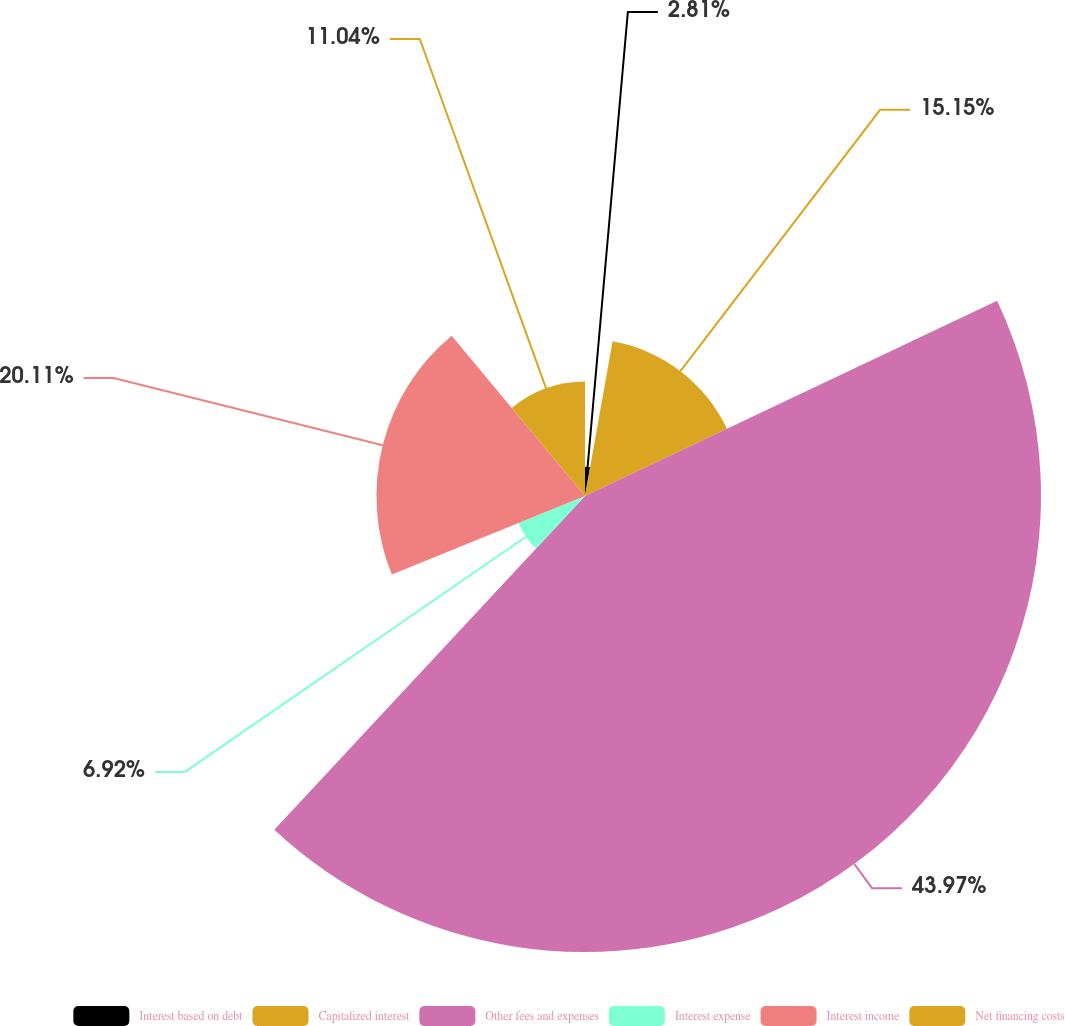<chart> <loc_0><loc_0><loc_500><loc_500><pie_chart><fcel>Interest based on debt<fcel>Capitalized interest<fcel>Other fees and expenses<fcel>Interest expense<fcel>Interest income<fcel>Net financing costs<nl><fcel>2.81%<fcel>15.15%<fcel>43.97%<fcel>6.92%<fcel>20.11%<fcel>11.04%<nl></chart> 